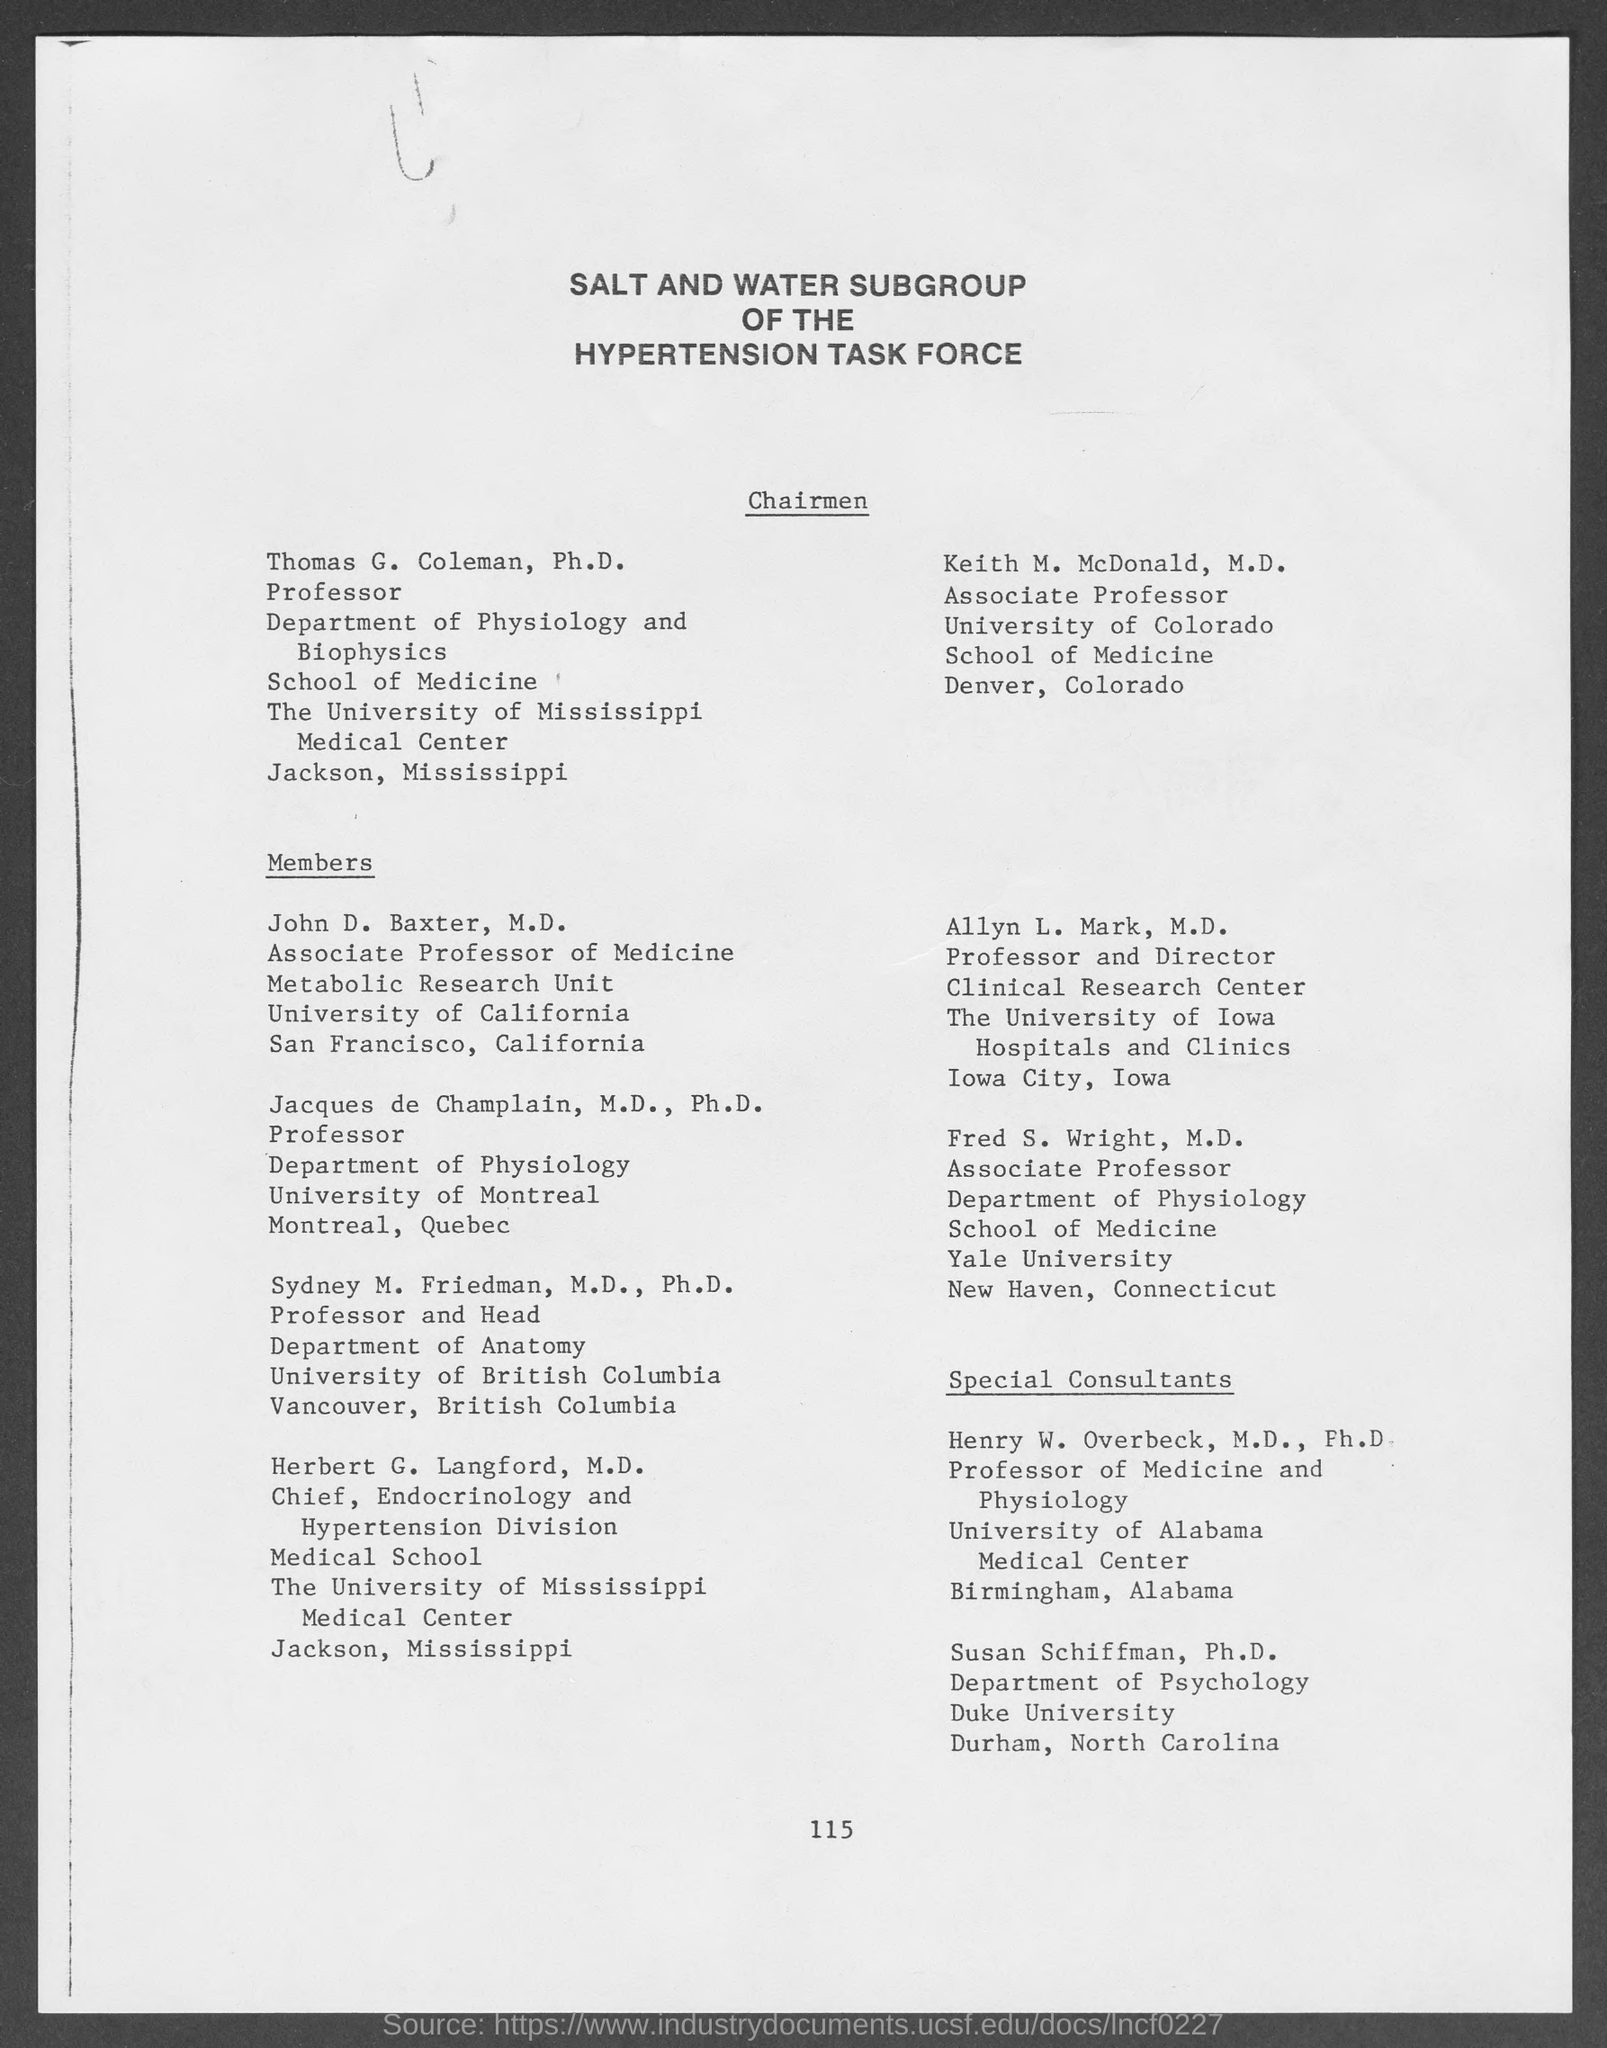Identify some key points in this picture. Allyn L. Mark, M.D., is the Professor and Director of the Clinical Research Center. Herbert G. Langford, M.D., is the Chief of the Endocrinology and Hypertension Division. 